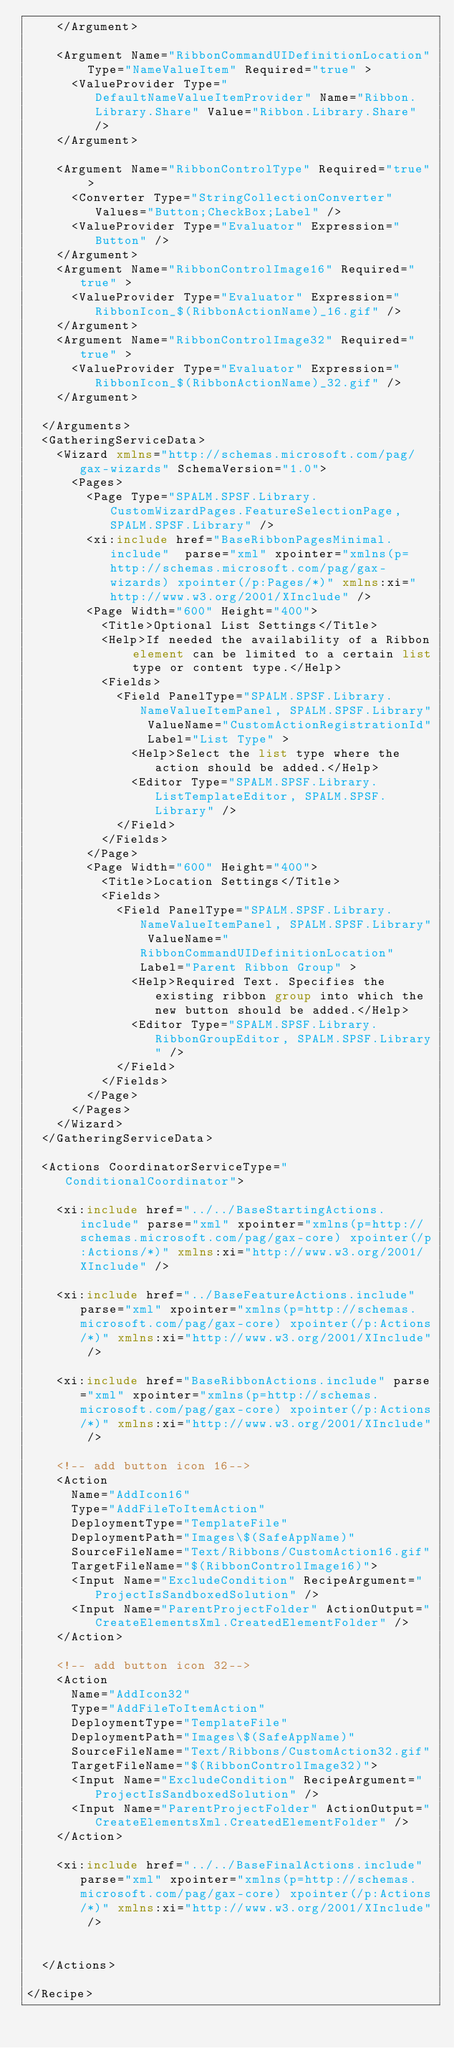<code> <loc_0><loc_0><loc_500><loc_500><_XML_>		</Argument>
		
		<Argument Name="RibbonCommandUIDefinitionLocation" Type="NameValueItem" Required="true" >
			<ValueProvider Type="DefaultNameValueItemProvider" Name="Ribbon.Library.Share" Value="Ribbon.Library.Share" />
		</Argument>	

		<Argument Name="RibbonControlType" Required="true" >
			<Converter Type="StringCollectionConverter" Values="Button;CheckBox;Label" />
			<ValueProvider Type="Evaluator" Expression="Button" />
		</Argument>
		<Argument Name="RibbonControlImage16" Required="true" >
			<ValueProvider Type="Evaluator" Expression="RibbonIcon_$(RibbonActionName)_16.gif" />
		</Argument>
		<Argument Name="RibbonControlImage32" Required="true" >
			<ValueProvider Type="Evaluator" Expression="RibbonIcon_$(RibbonActionName)_32.gif" />
		</Argument>

	</Arguments>
	<GatheringServiceData>
		<Wizard xmlns="http://schemas.microsoft.com/pag/gax-wizards" SchemaVersion="1.0">
			<Pages>
				<Page Type="SPALM.SPSF.Library.CustomWizardPages.FeatureSelectionPage, SPALM.SPSF.Library" />
				<xi:include href="BaseRibbonPagesMinimal.include"  parse="xml" xpointer="xmlns(p=http://schemas.microsoft.com/pag/gax-wizards) xpointer(/p:Pages/*)" xmlns:xi="http://www.w3.org/2001/XInclude" />
				<Page Width="600" Height="400">
					<Title>Optional List Settings</Title>
					<Help>If needed the availability of a Ribbon element can be limited to a certain list type or content type.</Help>
					<Fields>
						<Field PanelType="SPALM.SPSF.Library.NameValueItemPanel, SPALM.SPSF.Library" ValueName="CustomActionRegistrationId" Label="List Type" >
							<Help>Select the list type where the action should be added.</Help>
							<Editor Type="SPALM.SPSF.Library.ListTemplateEditor, SPALM.SPSF.Library" />
						</Field>
					</Fields>
				</Page>
				<Page Width="600" Height="400">
					<Title>Location Settings</Title>
					<Fields>
						<Field PanelType="SPALM.SPSF.Library.NameValueItemPanel, SPALM.SPSF.Library" ValueName="RibbonCommandUIDefinitionLocation" Label="Parent Ribbon Group" >
							<Help>Required Text. Specifies the existing ribbon group into which the new button should be added.</Help>
							<Editor Type="SPALM.SPSF.Library.RibbonGroupEditor, SPALM.SPSF.Library" />
						</Field>
					</Fields>
				</Page>
			</Pages>
		</Wizard>
	</GatheringServiceData>

	<Actions CoordinatorServiceType="ConditionalCoordinator">

		<xi:include href="../../BaseStartingActions.include" parse="xml" xpointer="xmlns(p=http://schemas.microsoft.com/pag/gax-core) xpointer(/p:Actions/*)" xmlns:xi="http://www.w3.org/2001/XInclude" />

		<xi:include href="../BaseFeatureActions.include" parse="xml" xpointer="xmlns(p=http://schemas.microsoft.com/pag/gax-core) xpointer(/p:Actions/*)" xmlns:xi="http://www.w3.org/2001/XInclude" />

		<xi:include href="BaseRibbonActions.include" parse="xml" xpointer="xmlns(p=http://schemas.microsoft.com/pag/gax-core) xpointer(/p:Actions/*)" xmlns:xi="http://www.w3.org/2001/XInclude" />

		<!-- add button icon 16-->
		<Action
		  Name="AddIcon16"
		  Type="AddFileToItemAction"
		  DeploymentType="TemplateFile"
		  DeploymentPath="Images\$(SafeAppName)"
		  SourceFileName="Text/Ribbons/CustomAction16.gif"
		  TargetFileName="$(RibbonControlImage16)">
			<Input Name="ExcludeCondition" RecipeArgument="ProjectIsSandboxedSolution" />
      <Input Name="ParentProjectFolder" ActionOutput="CreateElementsXml.CreatedElementFolder" />
		</Action>

		<!-- add button icon 32-->
		<Action
		  Name="AddIcon32"
		  Type="AddFileToItemAction"
		  DeploymentType="TemplateFile"
		  DeploymentPath="Images\$(SafeAppName)"
		  SourceFileName="Text/Ribbons/CustomAction32.gif"
		  TargetFileName="$(RibbonControlImage32)">
			<Input Name="ExcludeCondition" RecipeArgument="ProjectIsSandboxedSolution" />
      <Input Name="ParentProjectFolder" ActionOutput="CreateElementsXml.CreatedElementFolder" />
		</Action>

		<xi:include href="../../BaseFinalActions.include" parse="xml" xpointer="xmlns(p=http://schemas.microsoft.com/pag/gax-core) xpointer(/p:Actions/*)" xmlns:xi="http://www.w3.org/2001/XInclude" />


	</Actions>

</Recipe></code> 